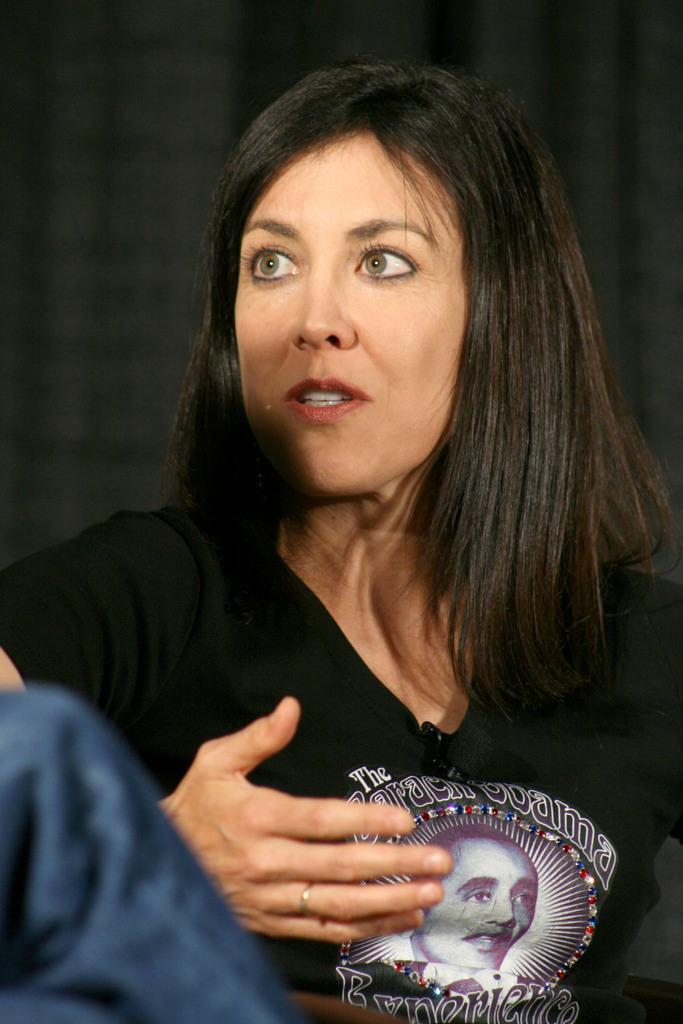In one or two sentences, can you explain what this image depicts? This picture shows a woman seated and she wore a black t-shirt and a black cloth on the back and we see a human seated on the side. 